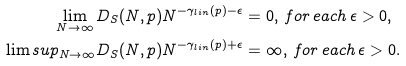Convert formula to latex. <formula><loc_0><loc_0><loc_500><loc_500>\lim _ { N \rightarrow \infty } D _ { S } ( N , p ) N ^ { - \gamma _ { l i n } ( p ) - \epsilon } & = 0 , \, f o r \, e a c h \, \epsilon > 0 , \\ \lim s u p _ { N \rightarrow \infty } D _ { S } ( N , p ) N ^ { - \gamma _ { l i n } ( p ) + \epsilon } & = \infty , \, f o r \, e a c h \, \epsilon > 0 .</formula> 